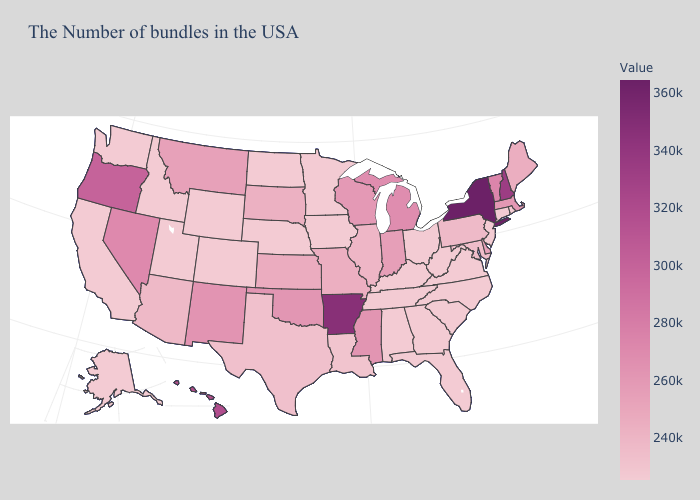Which states have the lowest value in the USA?
Write a very short answer. Rhode Island, Connecticut, New Jersey, Virginia, North Carolina, South Carolina, West Virginia, Ohio, Florida, Georgia, Kentucky, Alabama, Tennessee, Minnesota, Iowa, Nebraska, North Dakota, Wyoming, Colorado, Utah, Idaho, California, Alaska. Which states have the lowest value in the West?
Give a very brief answer. Wyoming, Colorado, Utah, Idaho, California, Alaska. Among the states that border Connecticut , which have the lowest value?
Answer briefly. Rhode Island. Which states have the highest value in the USA?
Short answer required. New York. Is the legend a continuous bar?
Short answer required. Yes. Among the states that border Wisconsin , does Michigan have the highest value?
Write a very short answer. Yes. Does New York have the highest value in the USA?
Keep it brief. Yes. Which states hav the highest value in the Northeast?
Quick response, please. New York. 